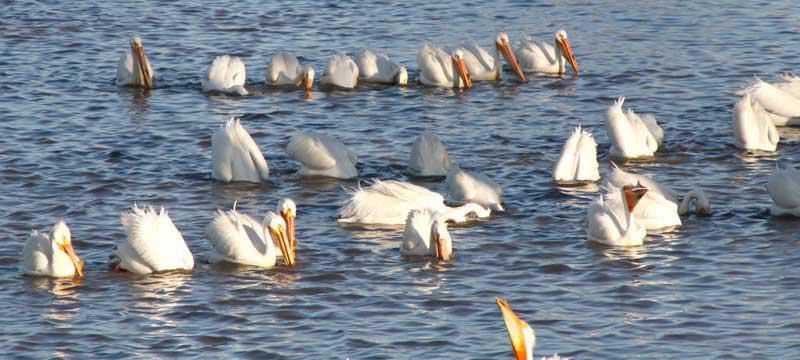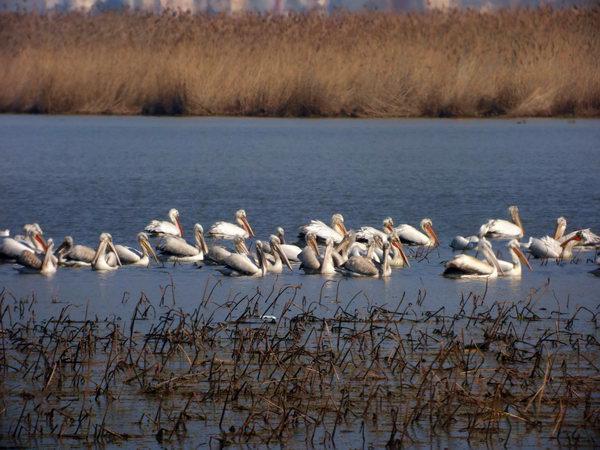The first image is the image on the left, the second image is the image on the right. Examine the images to the left and right. Is the description "An expanse of sandbar is visible under the pelicans." accurate? Answer yes or no. No. 